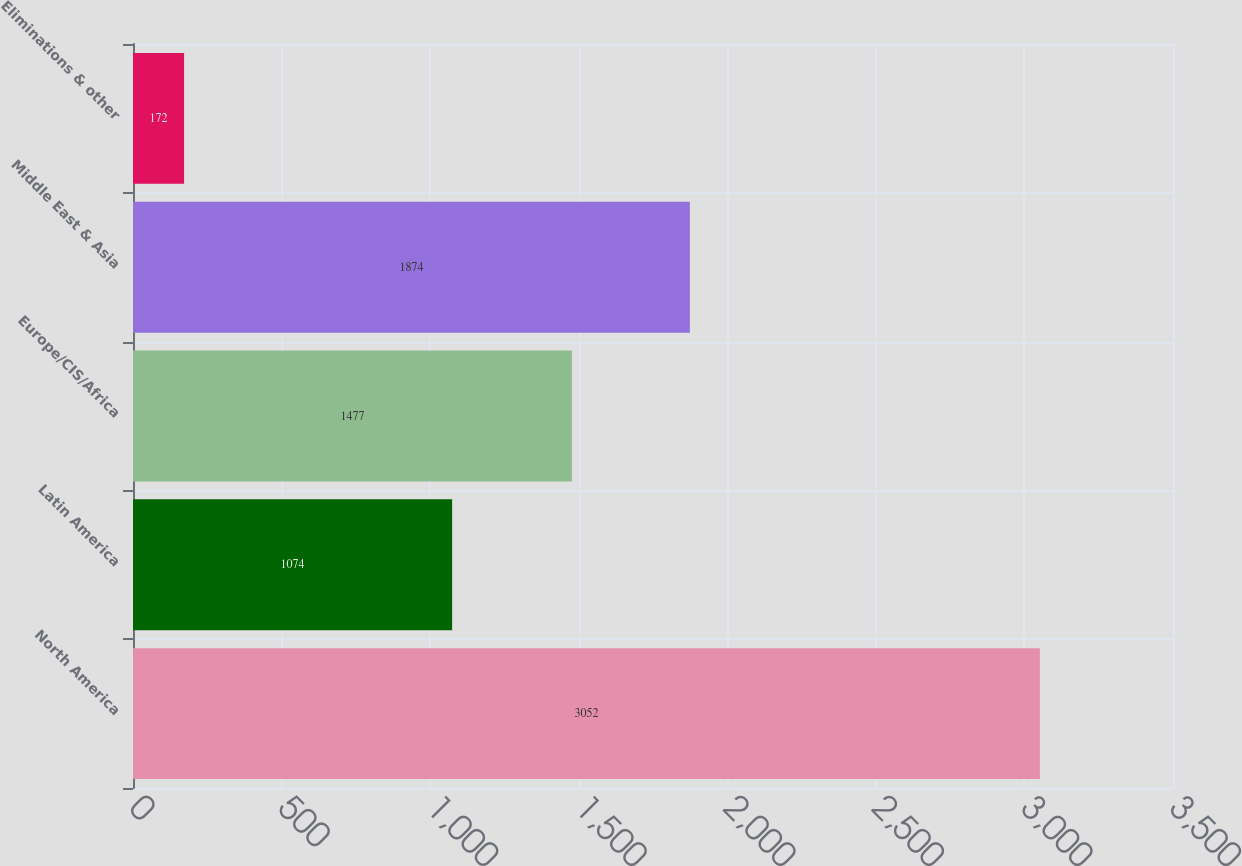Convert chart. <chart><loc_0><loc_0><loc_500><loc_500><bar_chart><fcel>North America<fcel>Latin America<fcel>Europe/CIS/Africa<fcel>Middle East & Asia<fcel>Eliminations & other<nl><fcel>3052<fcel>1074<fcel>1477<fcel>1874<fcel>172<nl></chart> 